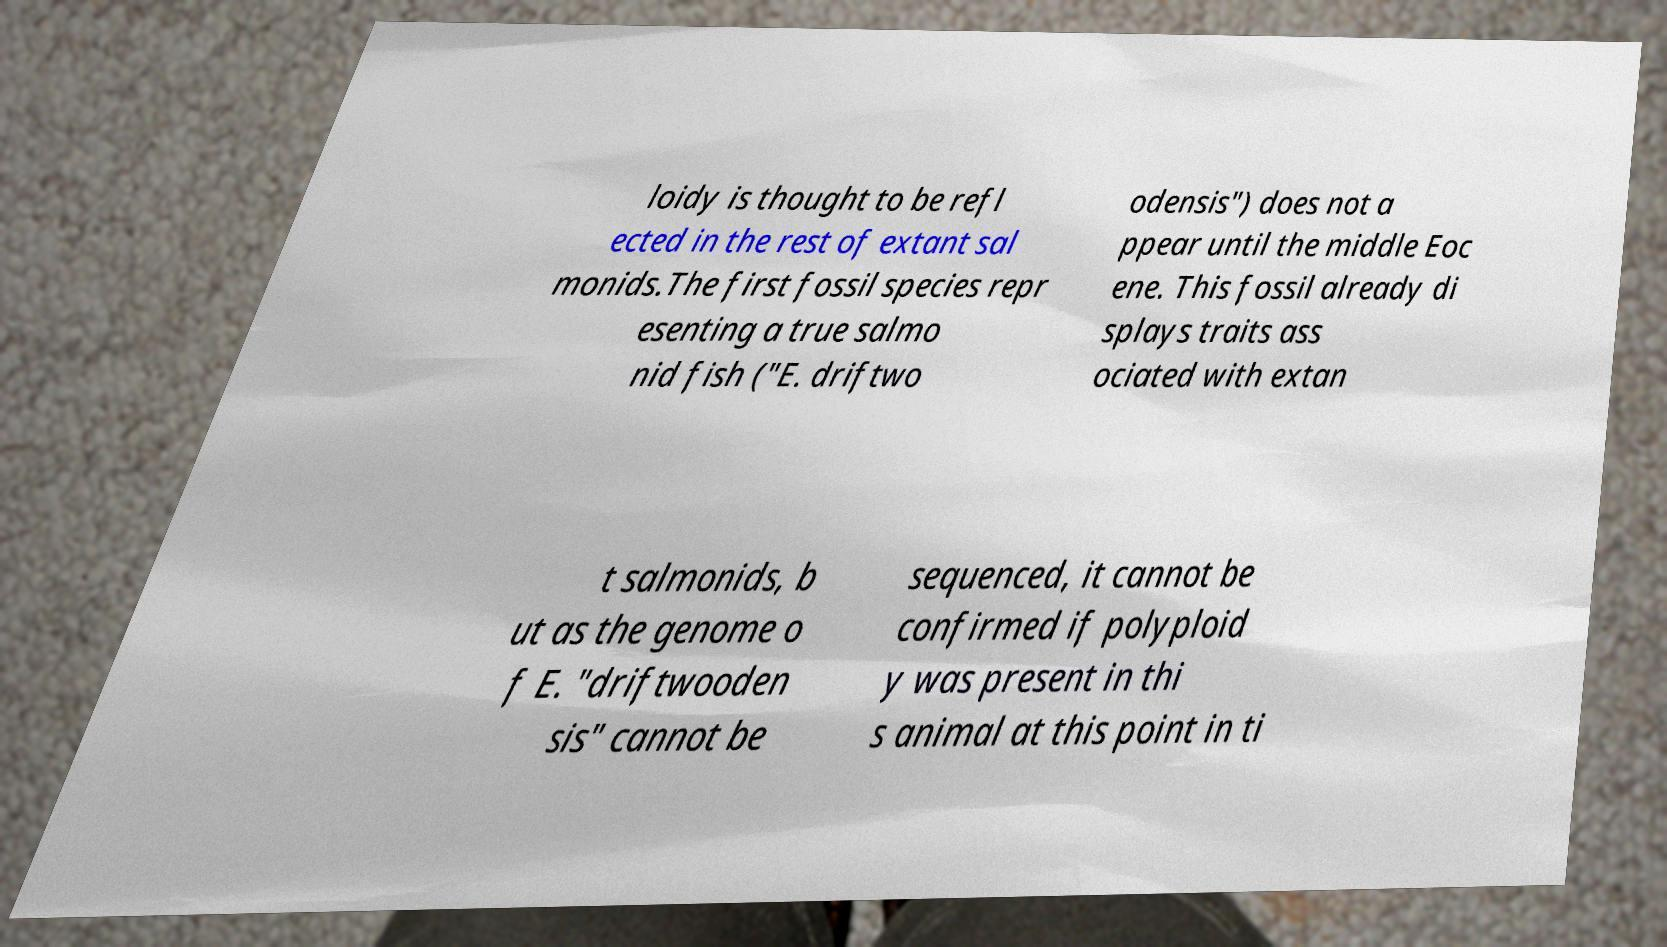Please read and relay the text visible in this image. What does it say? loidy is thought to be refl ected in the rest of extant sal monids.The first fossil species repr esenting a true salmo nid fish ("E. driftwo odensis") does not a ppear until the middle Eoc ene. This fossil already di splays traits ass ociated with extan t salmonids, b ut as the genome o f E. "driftwooden sis" cannot be sequenced, it cannot be confirmed if polyploid y was present in thi s animal at this point in ti 